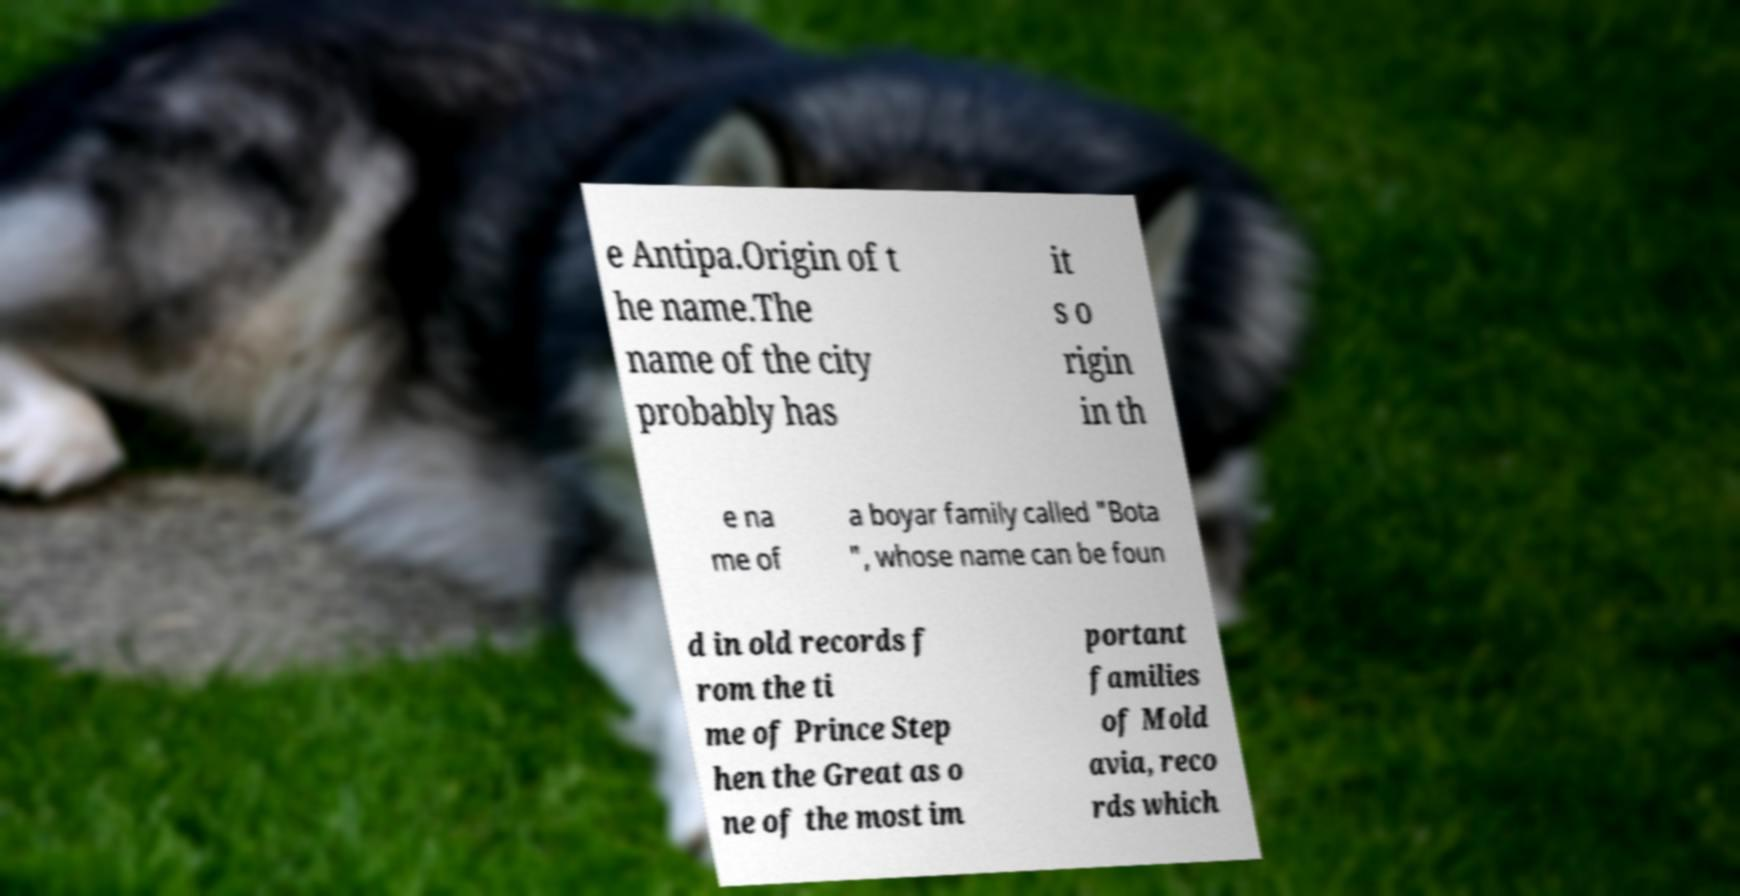For documentation purposes, I need the text within this image transcribed. Could you provide that? e Antipa.Origin of t he name.The name of the city probably has it s o rigin in th e na me of a boyar family called "Bota ", whose name can be foun d in old records f rom the ti me of Prince Step hen the Great as o ne of the most im portant families of Mold avia, reco rds which 